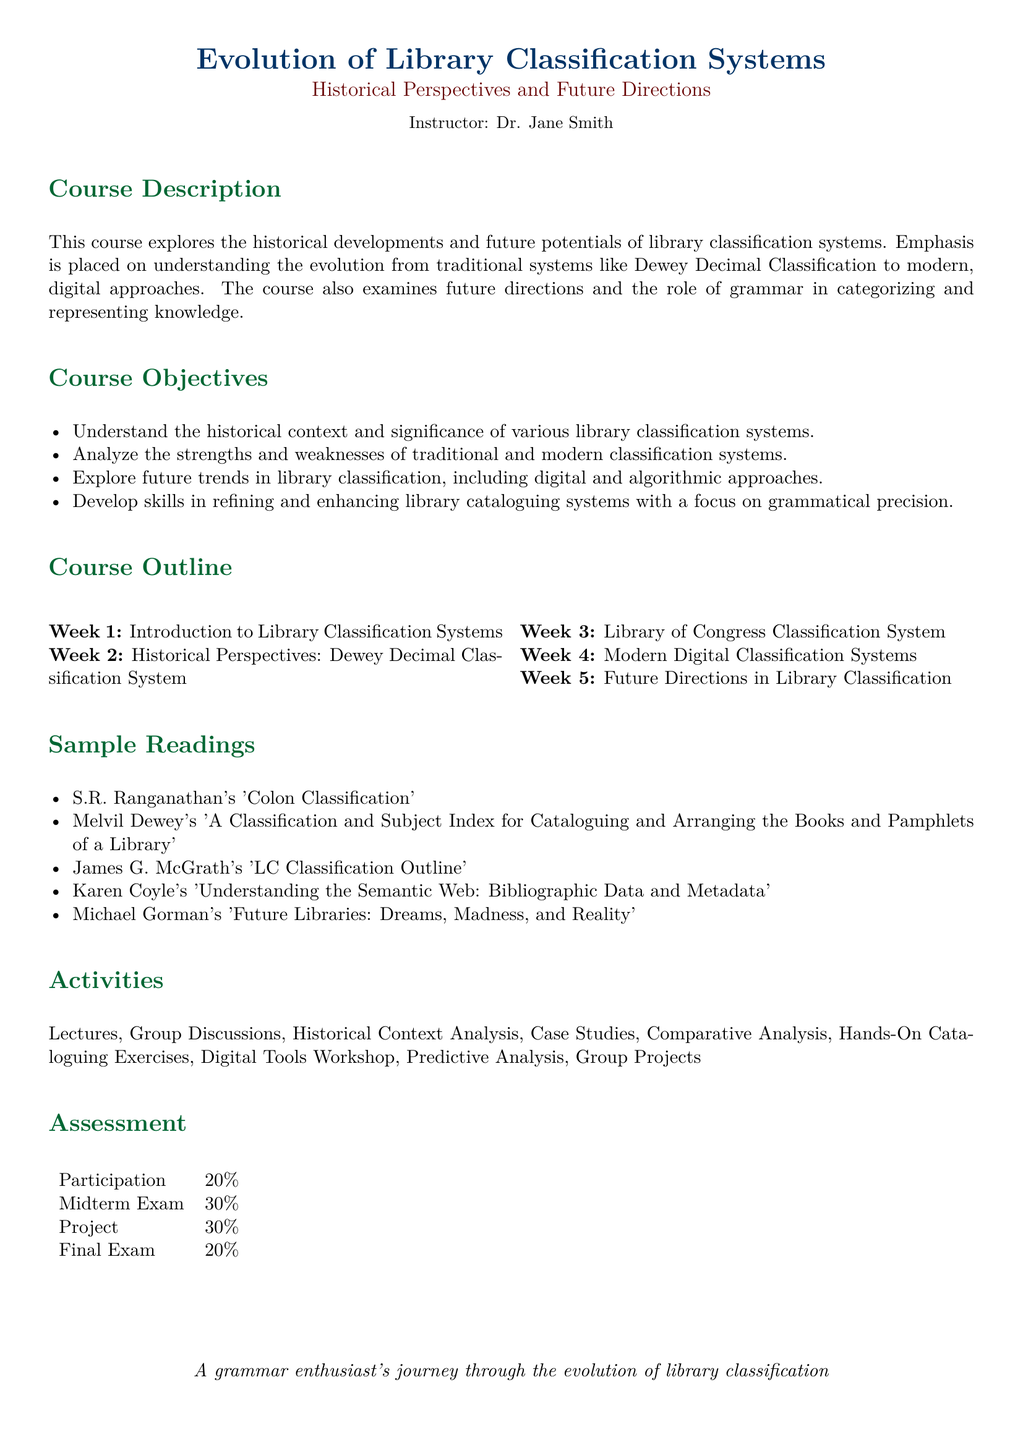What is the course title? The course title is prominently specified at the top of the document.
Answer: Evolution of Library Classification Systems Who is the instructor? The instructor's name is mentioned below the title in the document.
Answer: Dr. Jane Smith What percentage of the assessment is for the midterm exam? The midterm exam assessment percentage is listed in the assessment table in the document.
Answer: 30% Which week covers the Library of Congress Classification System? The corresponding week for this topic is outlined in the course outline section.
Answer: Week 3 What is one of the sample readings for this course? Sample readings are provided in a list; any single item from that list would suffice.
Answer: S.R. Ranganathan's 'Colon Classification' What is emphasized in the course regarding grammatical precision? This refers to a specific skill outlined in the course objectives section.
Answer: Refining and enhancing library cataloguing systems What type of analysis is included in the activities? The activities section lists various types of analyses performed during the course.
Answer: Comparative Analysis What course objective involves future trends? A specific objective in the course objectives section addresses future trends in library classification.
Answer: Explore future trends in library classification What is the total percentage of participation in assessments? The participation percentage is detailed in the assessment table in the document.
Answer: 20% 